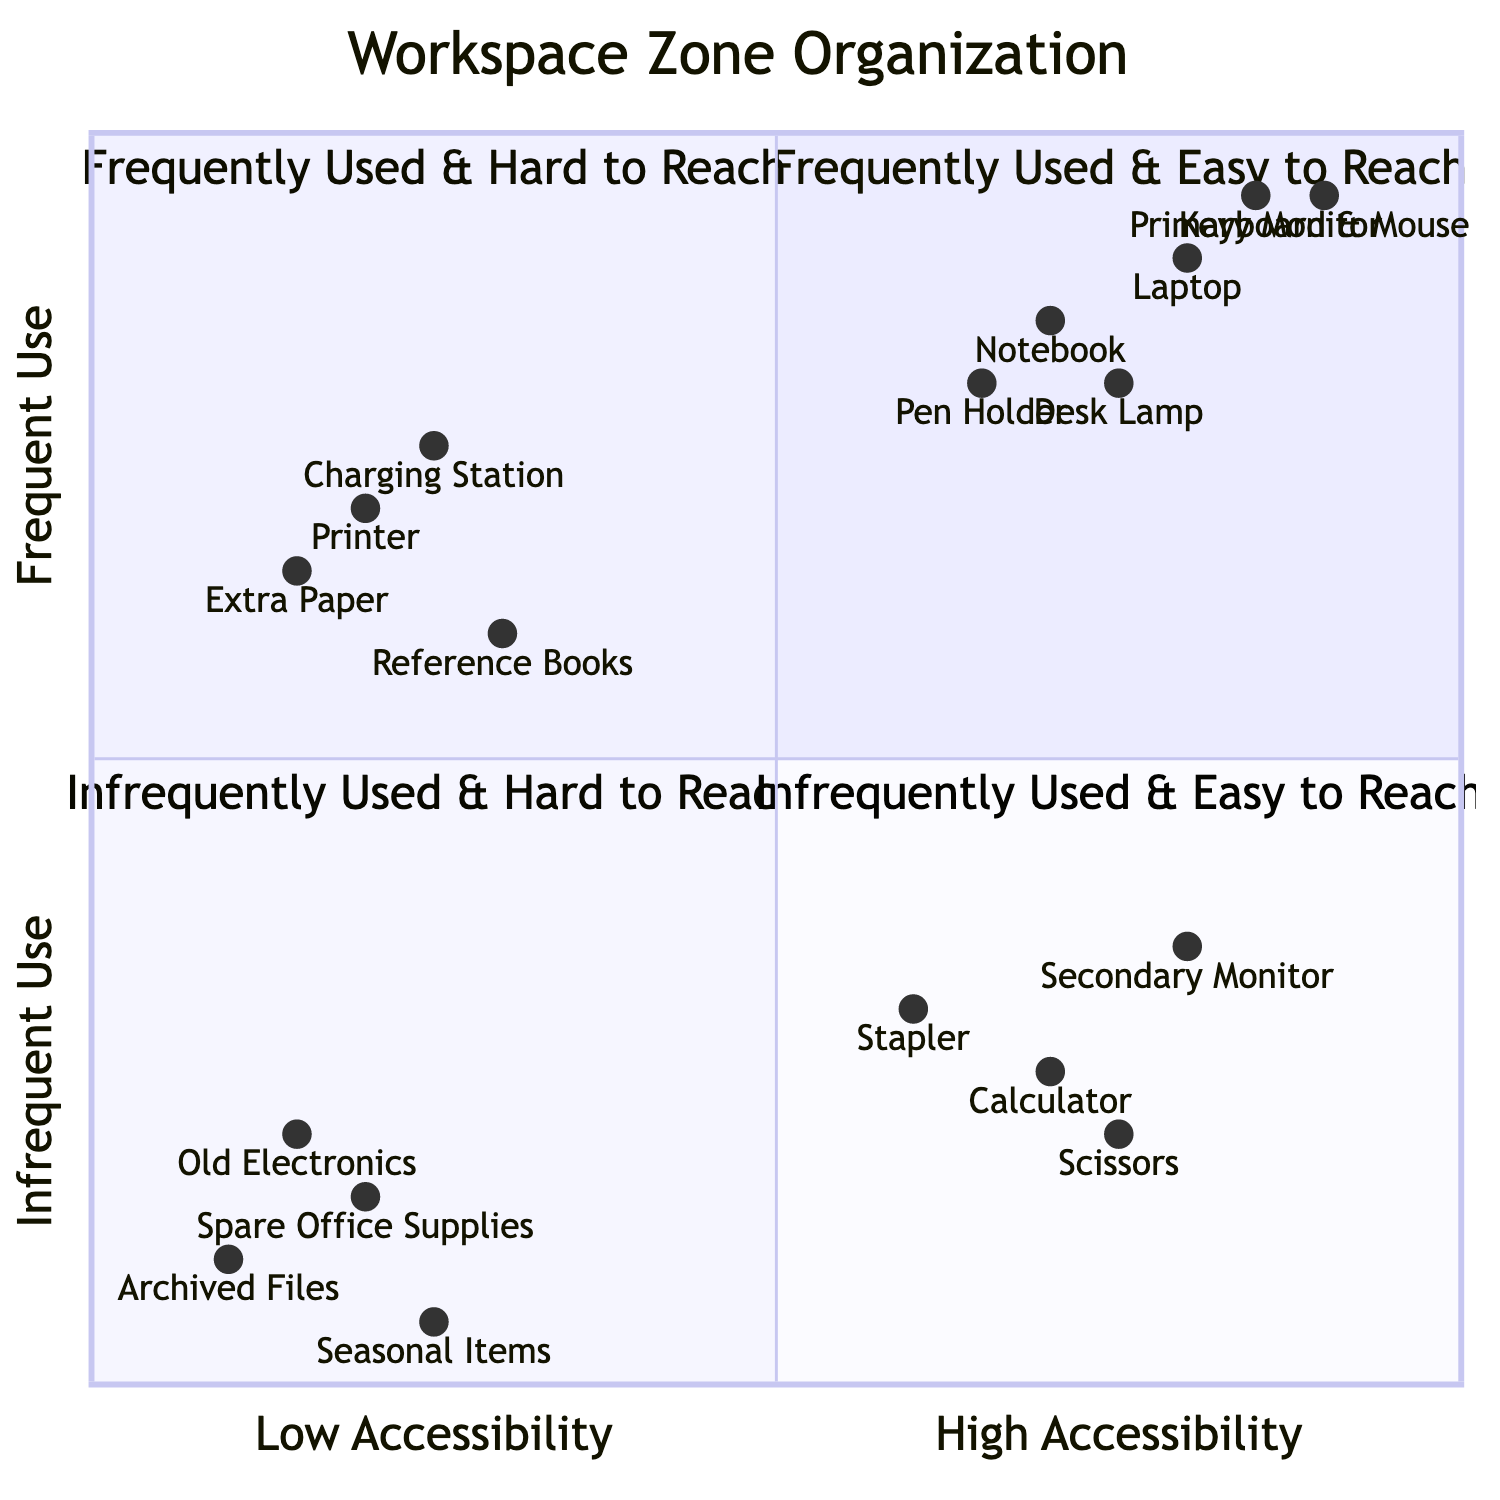What items are in the "Frequently Used & Easy to Reach" zone? By referring to the quadrant chart, items specifically listed in the "Frequently Used & Easy to Reach" zone are: Laptop, Primary Monitor, Keyboard & Mouse, Desk Lamp, Notebook, and Pen Holder.
Answer: Laptop, Primary Monitor, Keyboard & Mouse, Desk Lamp, Notebook, Pen Holder How many items are categorized as "Infrequently Used & Hard to Reach"? The "Infrequently Used & Hard to Reach" zone contains four listed items: Archived Files, Spare Office Supplies, Old Electronics, and Seasonal Items. Therefore, the count is four.
Answer: Four Which item is the least accessible in the "Frequently Used & Hard to Reach" quadrant? Among the elements in the "Frequently Used & Hard to Reach" quadrant, the item with the lowest accessibility coordinate is Extra Paper, which has a coordinate of 0.15.
Answer: Extra Paper What is the maximum accessibility score for items in the "Infrequently Used & Easy to Reach" section? The accessibility scores for this section range from 0.6 (Stapler) to 0.8 (Secondary Monitor). The highest score is 0.8 from the Secondary Monitor.
Answer: 0.8 How many zones contain items that are frequently used? There are two zones in the diagram that contain items categorized as frequently used: "Frequently Used & Easy to Reach" and "Frequently Used & Hard to Reach."
Answer: Two What is the highest frequency of use score in the quadrant chart? The highest frequency of use score belongs to the Primary Monitor, with a frequency score of 0.95, making it the highest.
Answer: 0.95 Which item is the most frequently used based on the highest y-coordinate? Based on the y-coordinate values, the item with the highest frequency is the Primary Monitor, which has a y-coordinate of 0.95.
Answer: Primary Monitor Which quadrant contains the item "Charging Station"? The Charging Station is listed under the "Frequently Used & Hard to Reach" zone based on its provided coordinates and categorization.
Answer: Frequently Used & Hard to Reach 